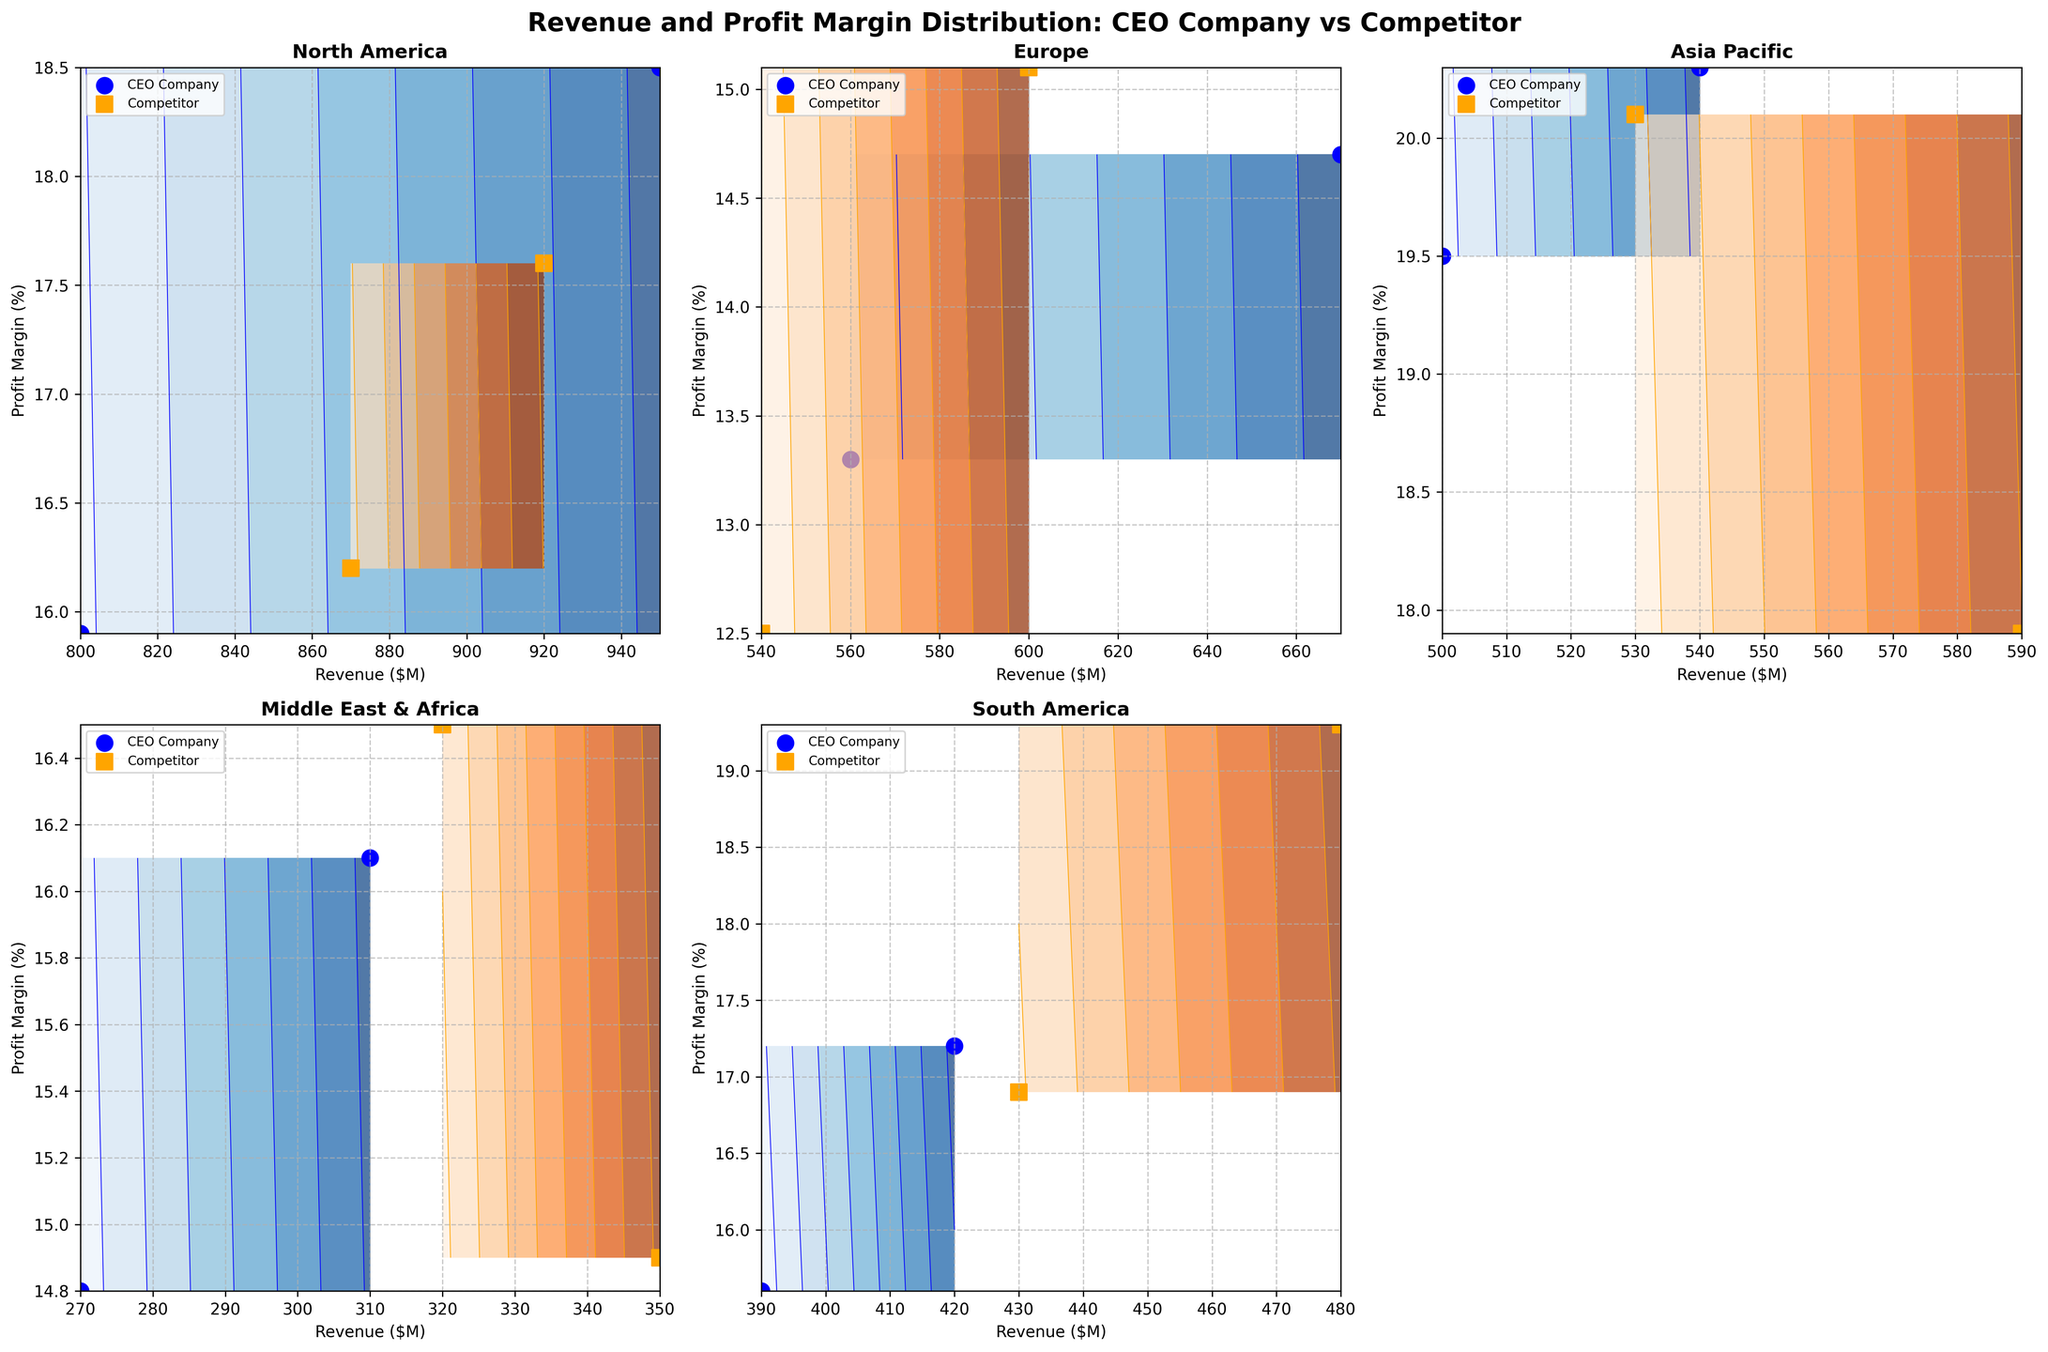Which region has the highest revenue for the CEO's Company? By examining the subplot titles and looking at the highest revenue values on the x-axis for each region, we can see that North America has the highest revenue marked around 950 for the CEO's Company.
Answer: North America What's the average profit margin percentage for the Competitor Company in the Europe and Asia Pacific regions? In Europe, the Competitor Company’s profit margin is approximately 12.5%. In the Asia Pacific region, it is around 20.1%. The average is calculated as (12.5 + 20.1) / 2 = 16.3%.
Answer: 16.3% Which company has a higher profit margin in the Middle East & Africa region? For the Middle East & Africa region subplot, the competitor's company has a higher profit margin at approximately 16.5%, compared to the CEO's company at around 16.1%.
Answer: Competitor's Company In which region do both companies have the closest revenue values? Observing the revenue values on the x-axis for each subplot, the Asia Pacific region has the most similar revenue values, with the CEO's company's revenue around 540 and the Competitor's company's revenue around 590.
Answer: Asia Pacific In which region does the Competitor Company outperform the CEO's Company both in revenue and profit margin? By examining both the revenue (x-axis) and profit margin (y-axis) for each region: In North America, South America, and Europe, the Competitor Company leads in either one or both metrics. However, Competitor Company outperforms in both revenue and profit margin in none of the regions.
Answer: None Which region has the least profit margin for the CEO’s Company? By referring to the y-axis values in all subplots, the Europe region has the least profit margin at approximately 13.3% for the CEO’s Company.
Answer: Europe How does the South America's revenue and profit margin compare for both companies? In South America, the Competitor's company has a revenue of around 480 and a profit margin approximately 19.3%, while the CEO’s company has a revenue of around 420 and profit margin around 17.2%. Thus, the Competitor's company has higher values in both metrics.
Answer: The Competitor's company has higher values in both metrics Which region has the highest profit margin for the CEO's company, and what is its value? Evaluating the y-axis values across all subplots for the CEO's company, the Asia Pacific region shows the highest profit margin, approximately around 20.3%.
Answer: Asia Pacific, 20.3% What is the difference in revenue between the CEO’s company and competitor in North America? In North America, the revenue for the CEO’s company is 950, and for the competitor, it is 870. The difference is computed as 950 - 870 = 80.
Answer: 80 In which regions does the CEO's company have higher revenue but lower profit margins compared to the competitor? Examining each subplot, in North America the CEO's company has higher revenue but lower profit margins. In South America, though both metrics are lower for the CEO's company. In other regions, we see other varying patterns.
Answer: North America 